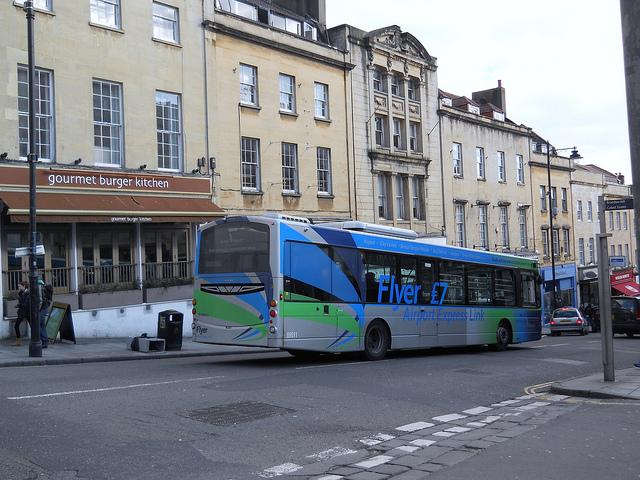What is the bus stopped outside of? Please explain your reasoning. restaurant. The bus is stopped outside the gourmet burger kitchen 